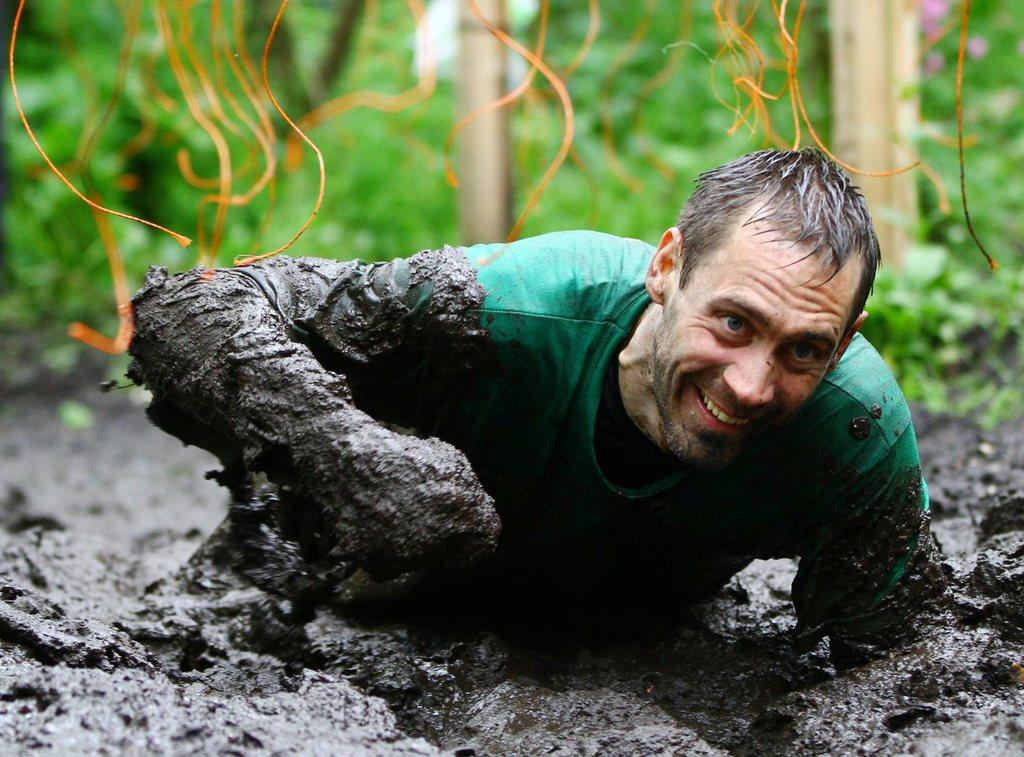Who or what is present in the image? There is a person in the image. What is the person's situation in the image? The person is in the mud. What can be seen in the background of the image? The background of the image is green and blurry. Can you describe any other elements in the image? There are unspecified objects in the image. What type of cannon is being adjusted by the cow in the image? There is no cannon or cow present in the image. 